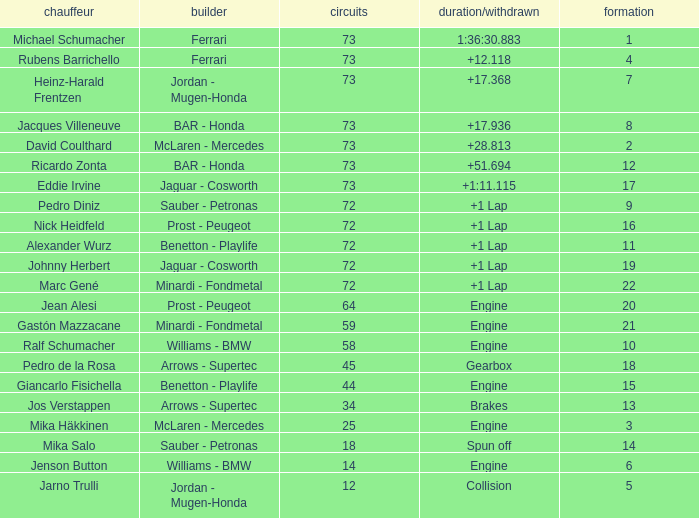How many laps did Jos Verstappen do on Grid 2? 34.0. 